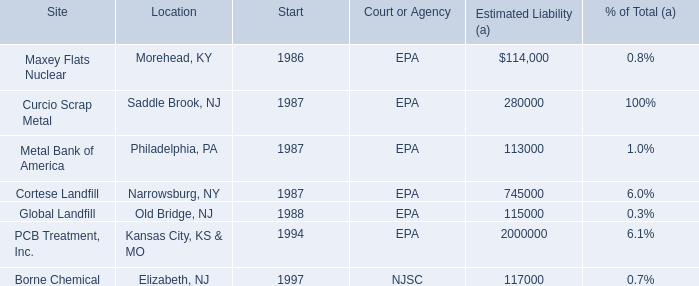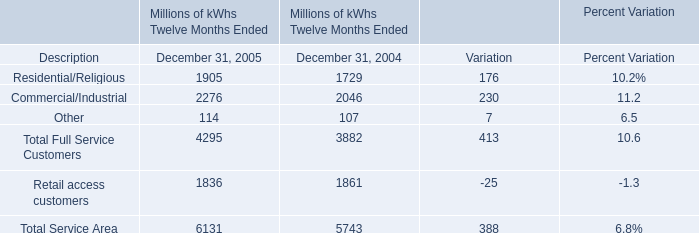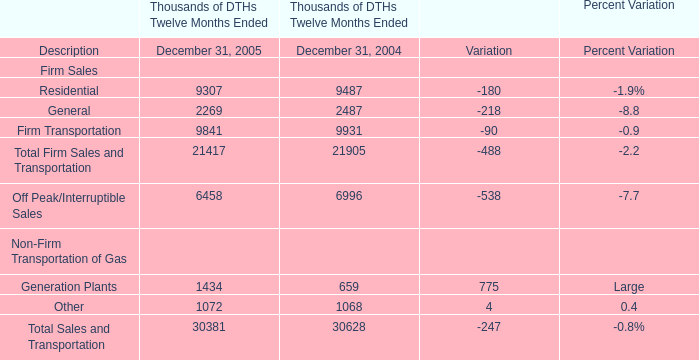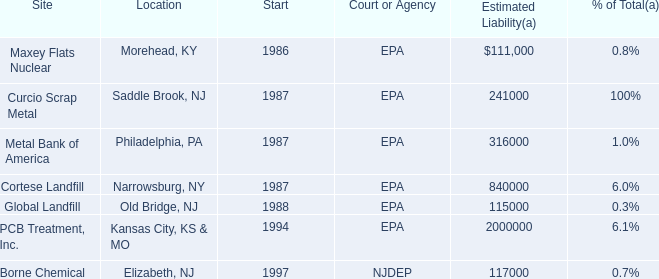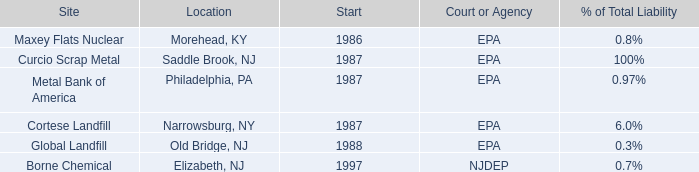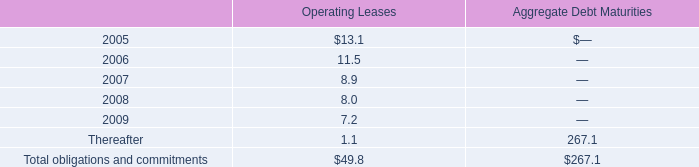what was the percentage change in total expense for all operating leases between 2003 and 2004? 
Computations: ((14.0 - 12.3) / 12.3)
Answer: 0.13821. 